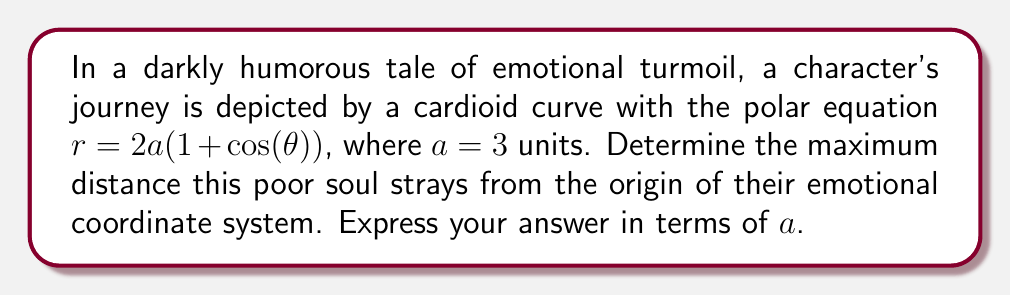Solve this math problem. Let's approach this problem step-by-step, with a touch of sardonic wit:

1) The cardioid equation is given as $r = 2a(1 + \cos(\theta))$, where $a = 3$.

2) To find the maximum distance from the origin, we need to find the maximum value of $r$. This occurs when $\cos(\theta)$ is at its maximum, which is 1.

3) When $\cos(\theta) = 1$, our equation becomes:
   $r_{max} = 2a(1 + 1) = 4a$

4) Substituting $a = 3$:
   $r_{max} = 4(3) = 12$ units

5) However, the question asks for the answer in terms of $a$, so we'll keep it as $4a$.

[asy]
import graph;
size(200);
real a = 3;
real r(real t) {return 2*a*(1+cos(t));}
path g = polar(r,0,2pi);
draw(g,red);
dot((4*a,0),blue);
label("$(4a,0)$",(4*a,0),E);
draw((-5,0)--(5,0),arrow=Arrow);
draw((0,-5)--(0,5),arrow=Arrow);
label("$x$",(5,0),E);
label("$y$",(0,5),N);
[/asy]

Our emotionally turbulent character reaches their furthest point from the origin at exactly $4a$ units. One can only hope they packed enough emotional baggage for such a journey.
Answer: $4a$ units 